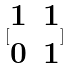<formula> <loc_0><loc_0><loc_500><loc_500>[ \begin{matrix} 1 & 1 \\ 0 & 1 \end{matrix} ]</formula> 